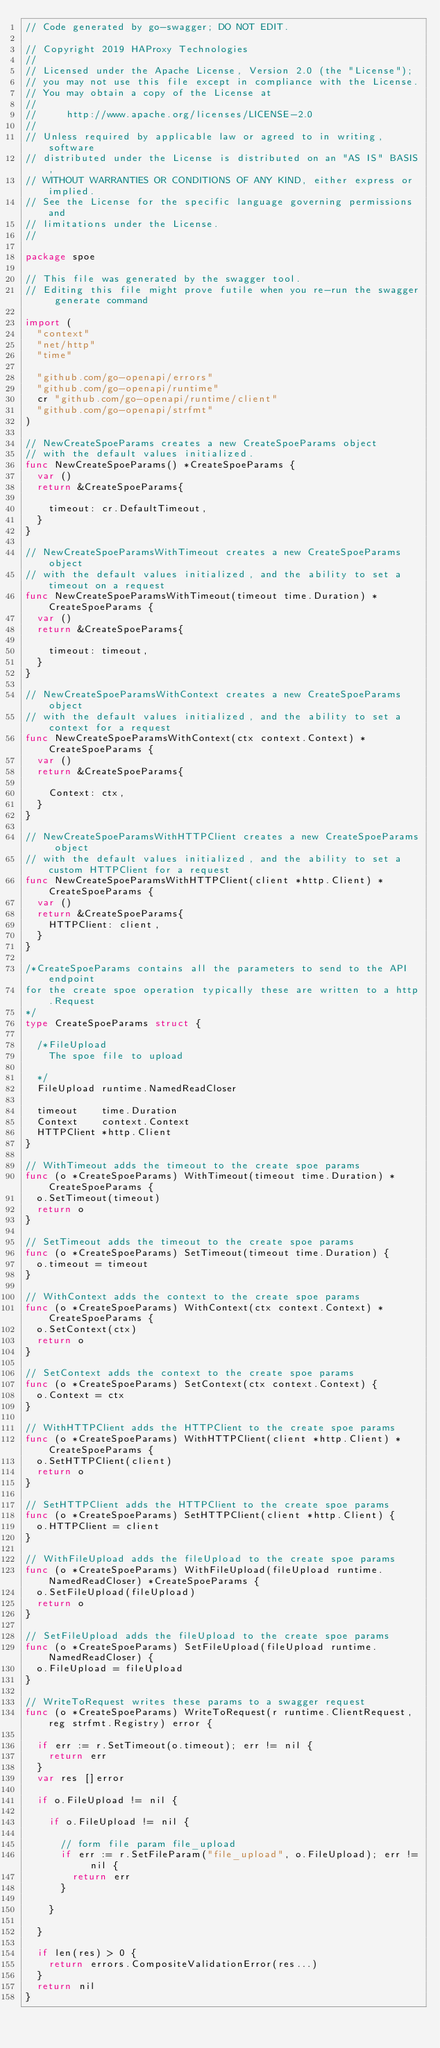Convert code to text. <code><loc_0><loc_0><loc_500><loc_500><_Go_>// Code generated by go-swagger; DO NOT EDIT.

// Copyright 2019 HAProxy Technologies
//
// Licensed under the Apache License, Version 2.0 (the "License");
// you may not use this file except in compliance with the License.
// You may obtain a copy of the License at
//
//     http://www.apache.org/licenses/LICENSE-2.0
//
// Unless required by applicable law or agreed to in writing, software
// distributed under the License is distributed on an "AS IS" BASIS,
// WITHOUT WARRANTIES OR CONDITIONS OF ANY KIND, either express or implied.
// See the License for the specific language governing permissions and
// limitations under the License.
//

package spoe

// This file was generated by the swagger tool.
// Editing this file might prove futile when you re-run the swagger generate command

import (
	"context"
	"net/http"
	"time"

	"github.com/go-openapi/errors"
	"github.com/go-openapi/runtime"
	cr "github.com/go-openapi/runtime/client"
	"github.com/go-openapi/strfmt"
)

// NewCreateSpoeParams creates a new CreateSpoeParams object
// with the default values initialized.
func NewCreateSpoeParams() *CreateSpoeParams {
	var ()
	return &CreateSpoeParams{

		timeout: cr.DefaultTimeout,
	}
}

// NewCreateSpoeParamsWithTimeout creates a new CreateSpoeParams object
// with the default values initialized, and the ability to set a timeout on a request
func NewCreateSpoeParamsWithTimeout(timeout time.Duration) *CreateSpoeParams {
	var ()
	return &CreateSpoeParams{

		timeout: timeout,
	}
}

// NewCreateSpoeParamsWithContext creates a new CreateSpoeParams object
// with the default values initialized, and the ability to set a context for a request
func NewCreateSpoeParamsWithContext(ctx context.Context) *CreateSpoeParams {
	var ()
	return &CreateSpoeParams{

		Context: ctx,
	}
}

// NewCreateSpoeParamsWithHTTPClient creates a new CreateSpoeParams object
// with the default values initialized, and the ability to set a custom HTTPClient for a request
func NewCreateSpoeParamsWithHTTPClient(client *http.Client) *CreateSpoeParams {
	var ()
	return &CreateSpoeParams{
		HTTPClient: client,
	}
}

/*CreateSpoeParams contains all the parameters to send to the API endpoint
for the create spoe operation typically these are written to a http.Request
*/
type CreateSpoeParams struct {

	/*FileUpload
	  The spoe file to upload

	*/
	FileUpload runtime.NamedReadCloser

	timeout    time.Duration
	Context    context.Context
	HTTPClient *http.Client
}

// WithTimeout adds the timeout to the create spoe params
func (o *CreateSpoeParams) WithTimeout(timeout time.Duration) *CreateSpoeParams {
	o.SetTimeout(timeout)
	return o
}

// SetTimeout adds the timeout to the create spoe params
func (o *CreateSpoeParams) SetTimeout(timeout time.Duration) {
	o.timeout = timeout
}

// WithContext adds the context to the create spoe params
func (o *CreateSpoeParams) WithContext(ctx context.Context) *CreateSpoeParams {
	o.SetContext(ctx)
	return o
}

// SetContext adds the context to the create spoe params
func (o *CreateSpoeParams) SetContext(ctx context.Context) {
	o.Context = ctx
}

// WithHTTPClient adds the HTTPClient to the create spoe params
func (o *CreateSpoeParams) WithHTTPClient(client *http.Client) *CreateSpoeParams {
	o.SetHTTPClient(client)
	return o
}

// SetHTTPClient adds the HTTPClient to the create spoe params
func (o *CreateSpoeParams) SetHTTPClient(client *http.Client) {
	o.HTTPClient = client
}

// WithFileUpload adds the fileUpload to the create spoe params
func (o *CreateSpoeParams) WithFileUpload(fileUpload runtime.NamedReadCloser) *CreateSpoeParams {
	o.SetFileUpload(fileUpload)
	return o
}

// SetFileUpload adds the fileUpload to the create spoe params
func (o *CreateSpoeParams) SetFileUpload(fileUpload runtime.NamedReadCloser) {
	o.FileUpload = fileUpload
}

// WriteToRequest writes these params to a swagger request
func (o *CreateSpoeParams) WriteToRequest(r runtime.ClientRequest, reg strfmt.Registry) error {

	if err := r.SetTimeout(o.timeout); err != nil {
		return err
	}
	var res []error

	if o.FileUpload != nil {

		if o.FileUpload != nil {

			// form file param file_upload
			if err := r.SetFileParam("file_upload", o.FileUpload); err != nil {
				return err
			}

		}

	}

	if len(res) > 0 {
		return errors.CompositeValidationError(res...)
	}
	return nil
}
</code> 